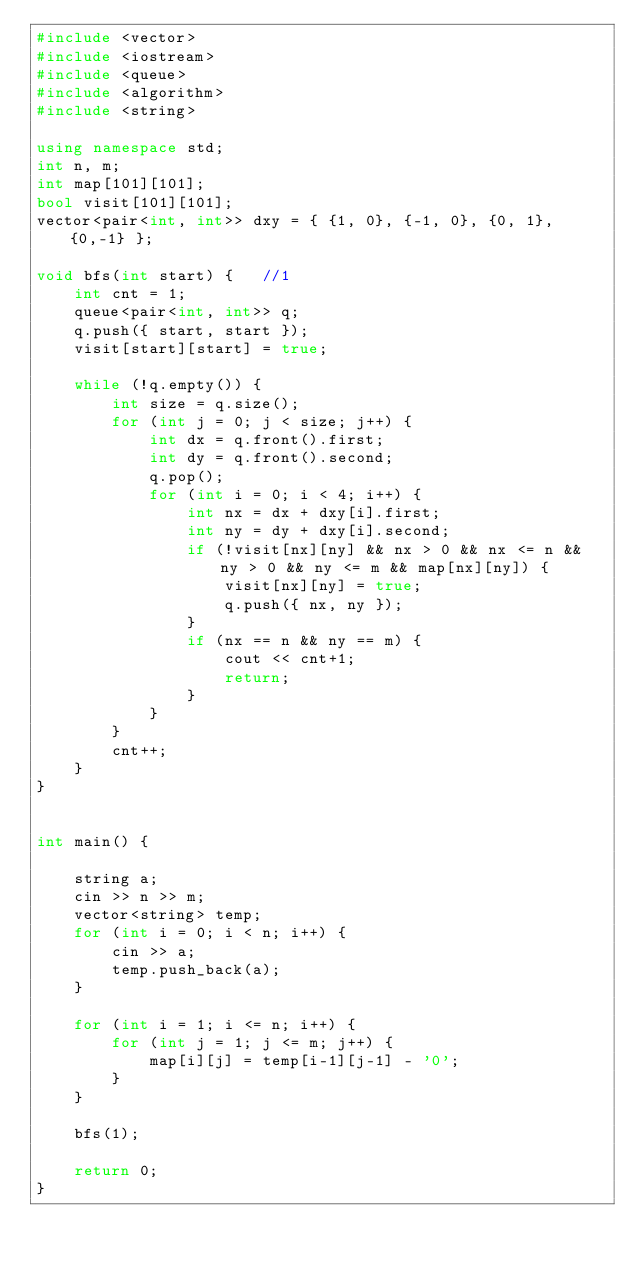<code> <loc_0><loc_0><loc_500><loc_500><_C++_>#include <vector>
#include <iostream>
#include <queue>
#include <algorithm>
#include <string>

using namespace std;
int n, m;
int map[101][101];
bool visit[101][101];
vector<pair<int, int>> dxy = { {1, 0}, {-1, 0}, {0, 1}, {0,-1} };

void bfs(int start) {	//1
	int cnt = 1;
	queue<pair<int, int>> q;
	q.push({ start, start });
	visit[start][start] = true;
	
	while (!q.empty()) {
		int size = q.size();
		for (int j = 0; j < size; j++) {
			int dx = q.front().first;
			int dy = q.front().second;
			q.pop();
			for (int i = 0; i < 4; i++) {
				int nx = dx + dxy[i].first;
				int ny = dy + dxy[i].second;
				if (!visit[nx][ny] && nx > 0 && nx <= n && ny > 0 && ny <= m && map[nx][ny]) {
					visit[nx][ny] = true;
					q.push({ nx, ny });
				}
				if (nx == n && ny == m) {
					cout << cnt+1;
					return;
				}
			}
		}
		cnt++;
	}
}


int main() {
	
	string a;
	cin >> n >> m;
	vector<string> temp;
	for (int i = 0; i < n; i++) {
		cin >> a;
		temp.push_back(a);
	}

	for (int i = 1; i <= n; i++) {
		for (int j = 1; j <= m; j++) {
			map[i][j] = temp[i-1][j-1] - '0';
		}
	}

	bfs(1);

	return 0;
}</code> 